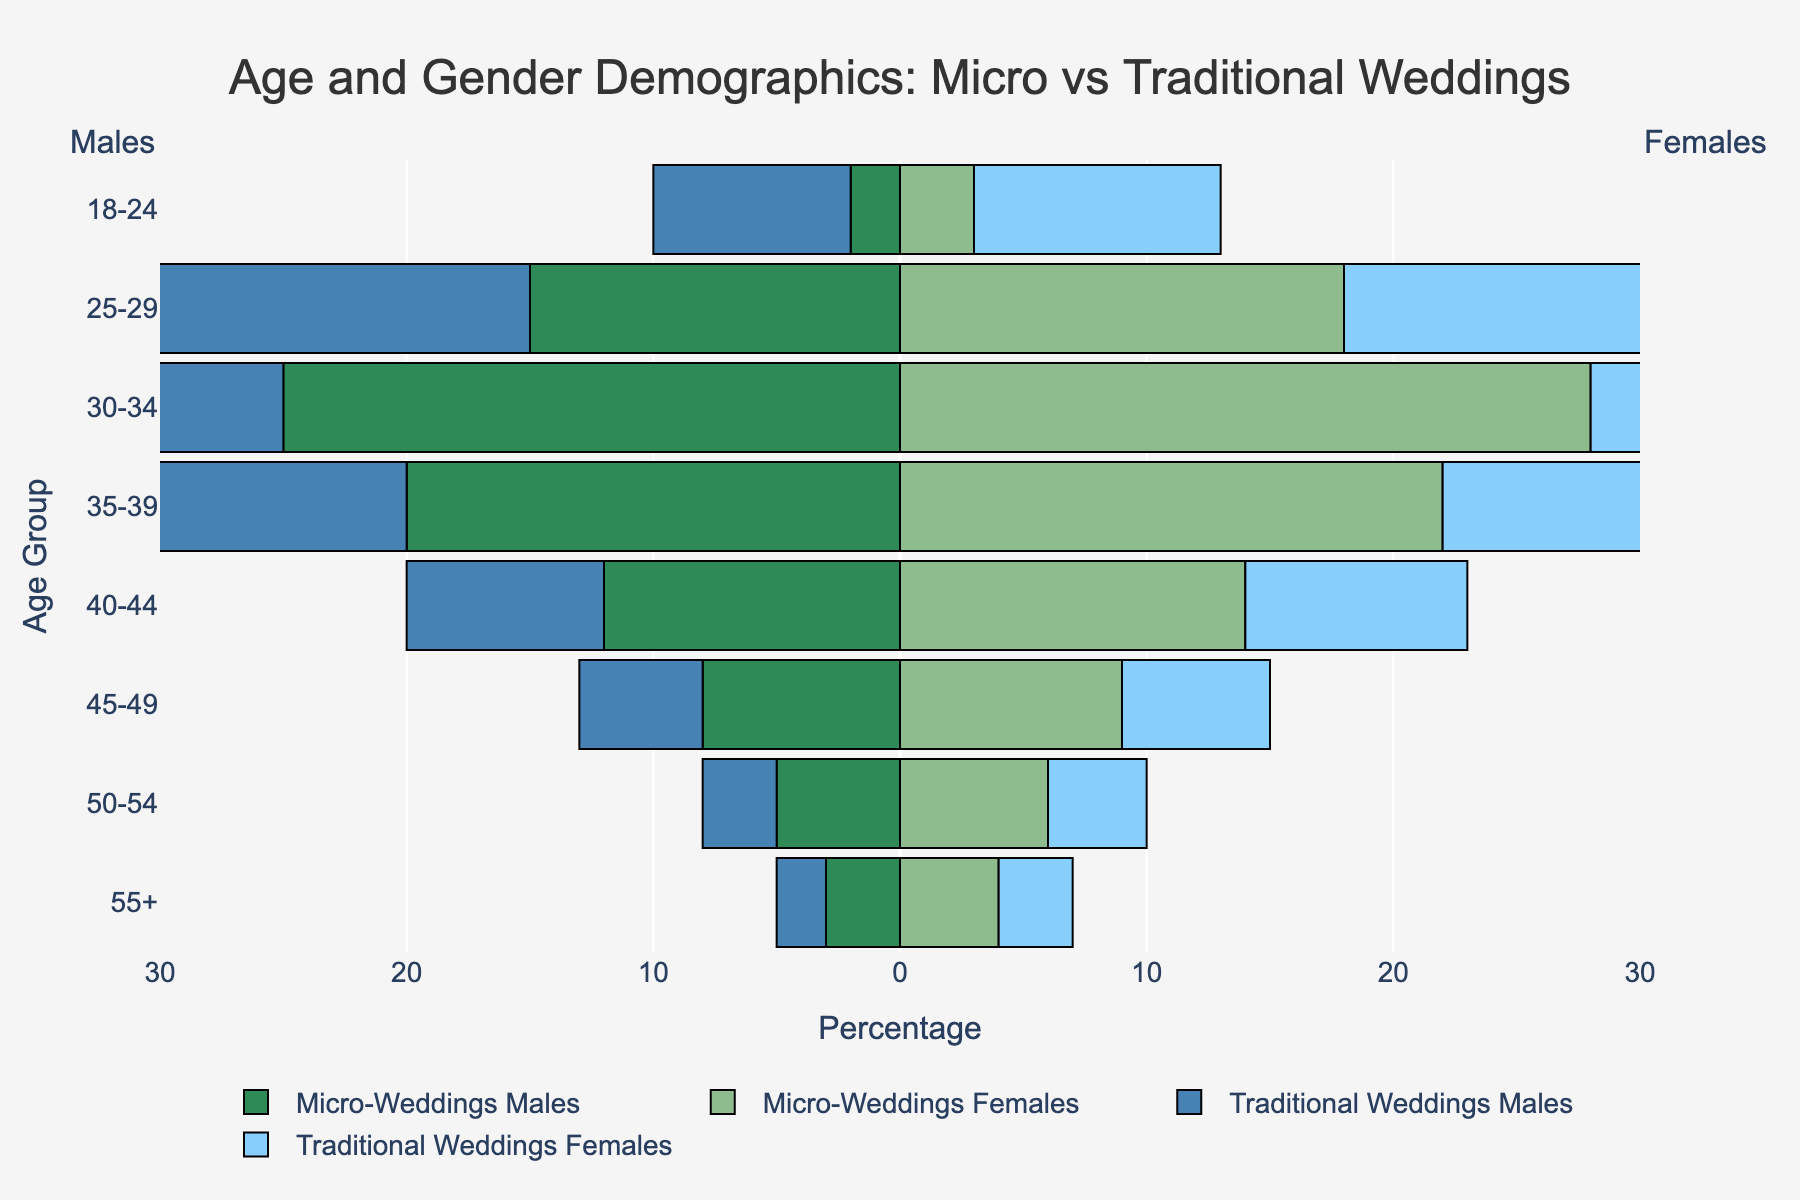Which age group has the highest number of males opting for micro-weddings? The highest number of males opting for micro-weddings is indicated by the longest bar on the negative side of the x-axis corresponding to "Micro-Weddings Males" color green, which is for the age group 30-34.
Answer: 30-34 Which gender has more attendees in traditional weddings across the age group 18-24? Comparing the bars for "Traditional Weddings Males" and "Traditional Weddings Females" in the age group 18-24, the bar for females (light blue) is longer than the bar for males (dark blue).
Answer: Females In which age group do micro-weddings have significantly more participants compared to traditional weddings? Looking at micro-weddings and traditional weddings bars for each age group, for the age group 35-39, "Micro-Weddings" bars are significantly longer than "Traditional Weddings" bars.
Answer: 35-39 What is the total number of attendees for traditional weddings in the age group 50-54? Summing up the "Traditional Weddings Males" and "Traditional Weddings Females" for the age group 50-54: 3 (males) + 4 (females) = 7.
Answer: 7 Which age group shows the smallest representation in micro-weddings? The smallest representation in micro-weddings is indicated by the shortest bars for "Micro-Weddings Males" and "Micro-Weddings Females" combined, which occurs in the age group 55+.
Answer: 55+ How do the numbers of males and females attending micro-weddings in the age group 25-29 compare? The bars for "Micro-Weddings Males" and "Micro-Weddings Females" in the age group 25-29 are nearly equal in length, with females being slightly higher (18 vs 15).
Answer: Females are slightly more What is the combined number of females in micro-weddings and traditional weddings for the age group 45-49? Summing the "Micro-Weddings Females" (9) and "Traditional Weddings Females" (6) bars for the age group 45-49: 9 + 6 = 15.
Answer: 15 Which age group sees a higher count of males than females for micro-weddings? Checking bars for "Micro-Weddings Males" and "Micro-Weddings Females" for each age group, males are more in the group 30-34 (25 vs 28), thus no age group shows higher male counts.
Answer: None How does the male participation in traditional weddings change from age group 25-29 to 30-34? The "Traditional Weddings Males" bar is shorter in age group 30-34 (18) compared to age group 25-29 (22).
Answer: Decreases Which age group has the highest difference between the number of females attending micro-weddings and traditional weddings? Subtract the "Traditional Weddings Females" from "Micro-Weddings Females" for each age group; the highest difference is in age group 30-34 (28 - 20 = 8).
Answer: 30-34 